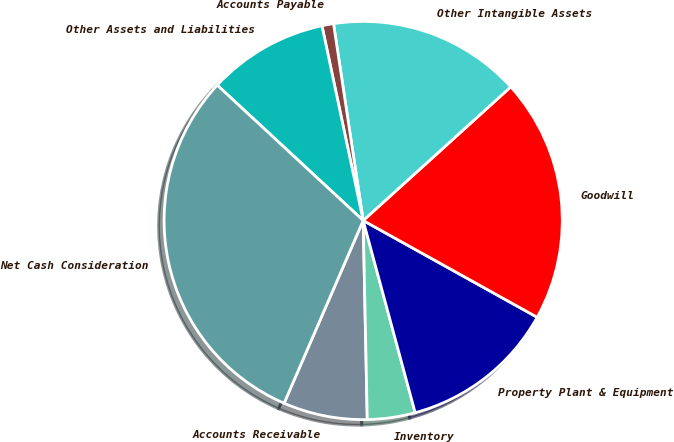<chart> <loc_0><loc_0><loc_500><loc_500><pie_chart><fcel>Accounts Receivable<fcel>Inventory<fcel>Property Plant & Equipment<fcel>Goodwill<fcel>Other Intangible Assets<fcel>Accounts Payable<fcel>Other Assets and Liabilities<fcel>Net Cash Consideration<nl><fcel>6.83%<fcel>3.88%<fcel>12.72%<fcel>19.79%<fcel>15.67%<fcel>0.94%<fcel>9.78%<fcel>30.4%<nl></chart> 